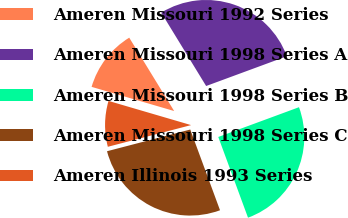Convert chart. <chart><loc_0><loc_0><loc_500><loc_500><pie_chart><fcel>Ameren Missouri 1992 Series<fcel>Ameren Missouri 1998 Series A<fcel>Ameren Missouri 1998 Series B<fcel>Ameren Missouri 1998 Series C<fcel>Ameren Illinois 1993 Series<nl><fcel>11.72%<fcel>28.12%<fcel>25.0%<fcel>26.56%<fcel>8.59%<nl></chart> 